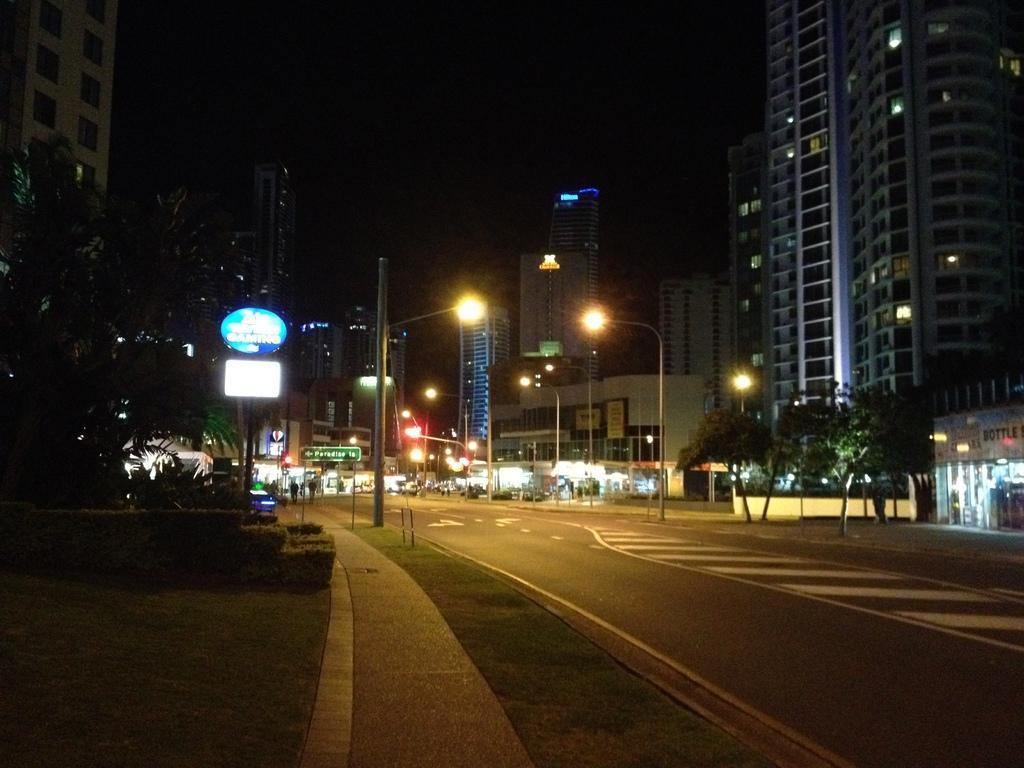In one or two sentences, can you explain what this image depicts? In this image we can see buildings, light poles, trees, there are boards with some text on it, there are sin boards, also the background is dark. 